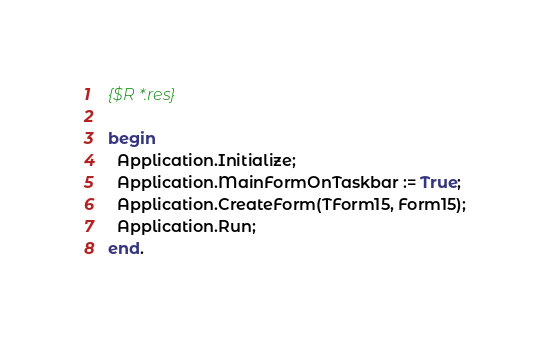Convert code to text. <code><loc_0><loc_0><loc_500><loc_500><_Pascal_>
{$R *.res}

begin
  Application.Initialize;
  Application.MainFormOnTaskbar := True;
  Application.CreateForm(TForm15, Form15);
  Application.Run;
end.
</code> 